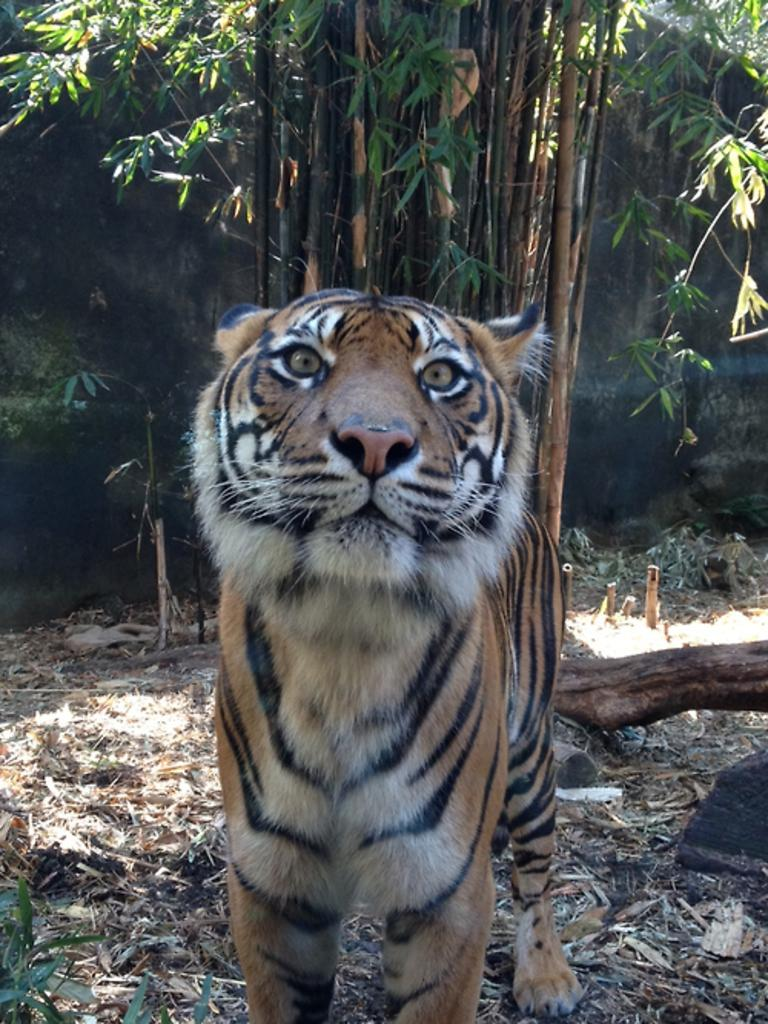What is the main subject in the center of the image? There is a tiger in the center of the image. What can be seen in the background of the image? There are trees and leaves in the background of the image. What type of soup is being served in the carriage in the image? There is no carriage or soup present in the image; it features a tiger and trees in the background. 